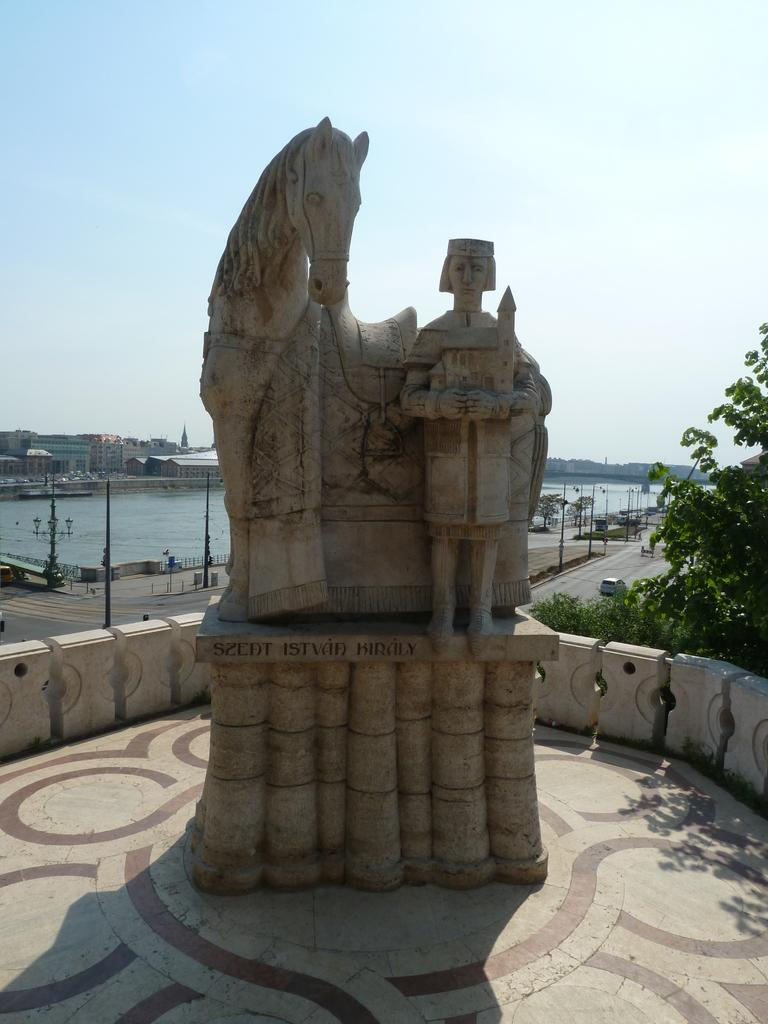What is depicted in the sculpture in the image? There is a sculpture of a horse and a man in the image. What can be seen on the right side of the image? There is a tree at the right side of the image. What type of objects are visible in the image? There are vehicles visible in the image. What structures are present on the road in the image? There are poles on the road in the image. What is visible in the background of the image? There is water and buildings visible in the background of the image. What type of fan is visible in the image? There is no fan present in the image. What type of engine can be seen powering the sculpture in the image? The sculpture is not a functioning object, so there is no engine present in the image. 